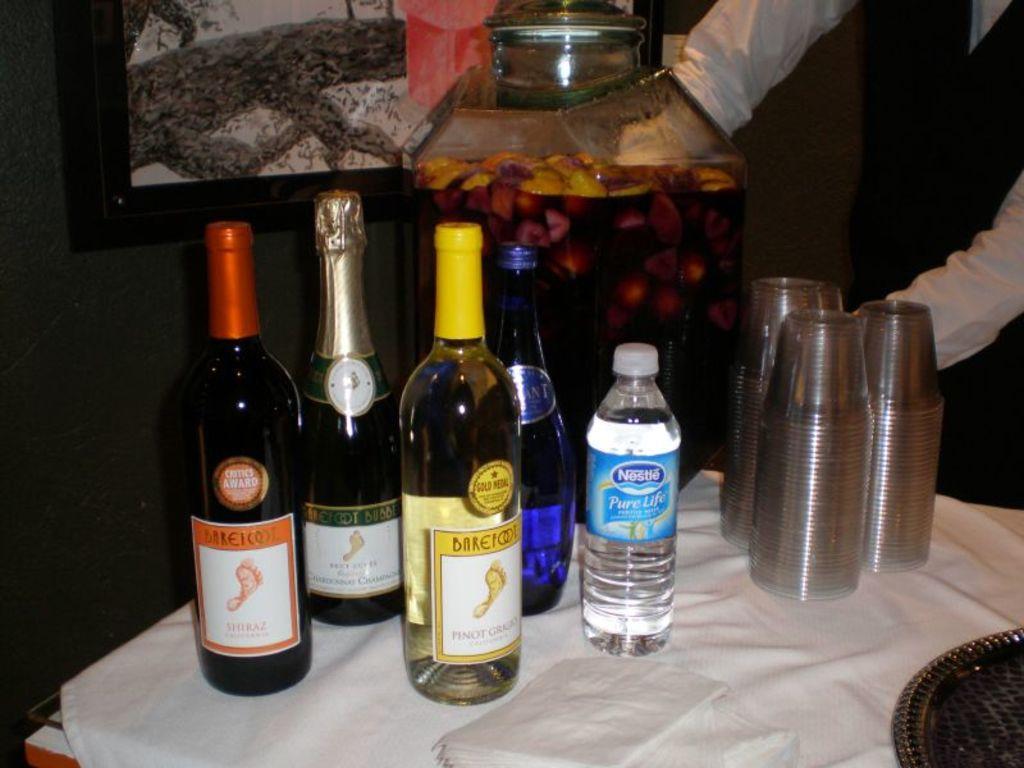How would you summarize this image in a sentence or two? On the table we can see there are many drink bottle, water bottle and glasses. There is a person standing. This is a white cloth on the table. 